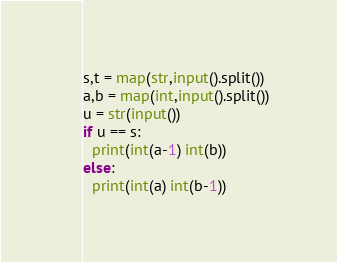<code> <loc_0><loc_0><loc_500><loc_500><_Python_>s,t = map(str,input().split())
a,b = map(int,input().split())
u = str(input())
if u == s:
  print(int(a-1) int(b))
else:
  print(int(a) int(b-1))</code> 